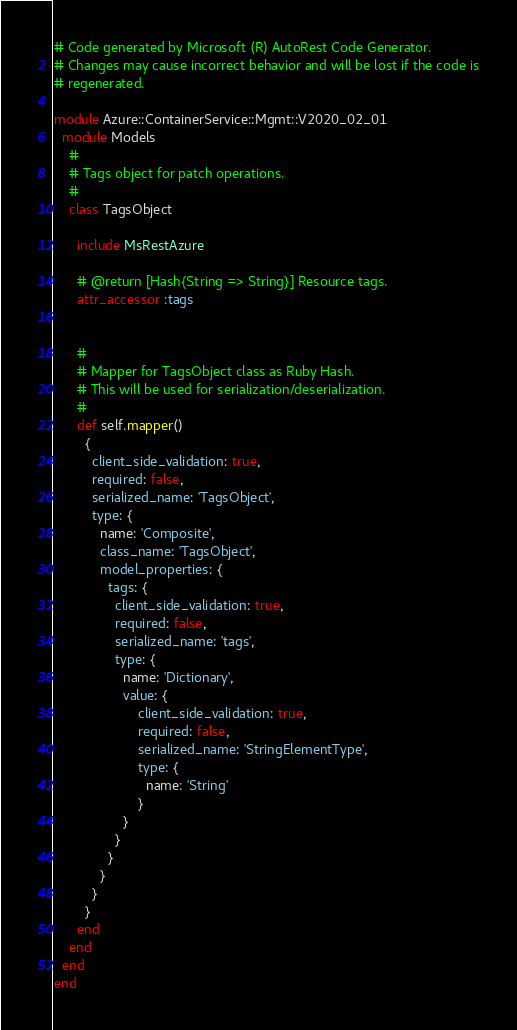<code> <loc_0><loc_0><loc_500><loc_500><_Ruby_># Code generated by Microsoft (R) AutoRest Code Generator.
# Changes may cause incorrect behavior and will be lost if the code is
# regenerated.

module Azure::ContainerService::Mgmt::V2020_02_01
  module Models
    #
    # Tags object for patch operations.
    #
    class TagsObject

      include MsRestAzure

      # @return [Hash{String => String}] Resource tags.
      attr_accessor :tags


      #
      # Mapper for TagsObject class as Ruby Hash.
      # This will be used for serialization/deserialization.
      #
      def self.mapper()
        {
          client_side_validation: true,
          required: false,
          serialized_name: 'TagsObject',
          type: {
            name: 'Composite',
            class_name: 'TagsObject',
            model_properties: {
              tags: {
                client_side_validation: true,
                required: false,
                serialized_name: 'tags',
                type: {
                  name: 'Dictionary',
                  value: {
                      client_side_validation: true,
                      required: false,
                      serialized_name: 'StringElementType',
                      type: {
                        name: 'String'
                      }
                  }
                }
              }
            }
          }
        }
      end
    end
  end
end
</code> 